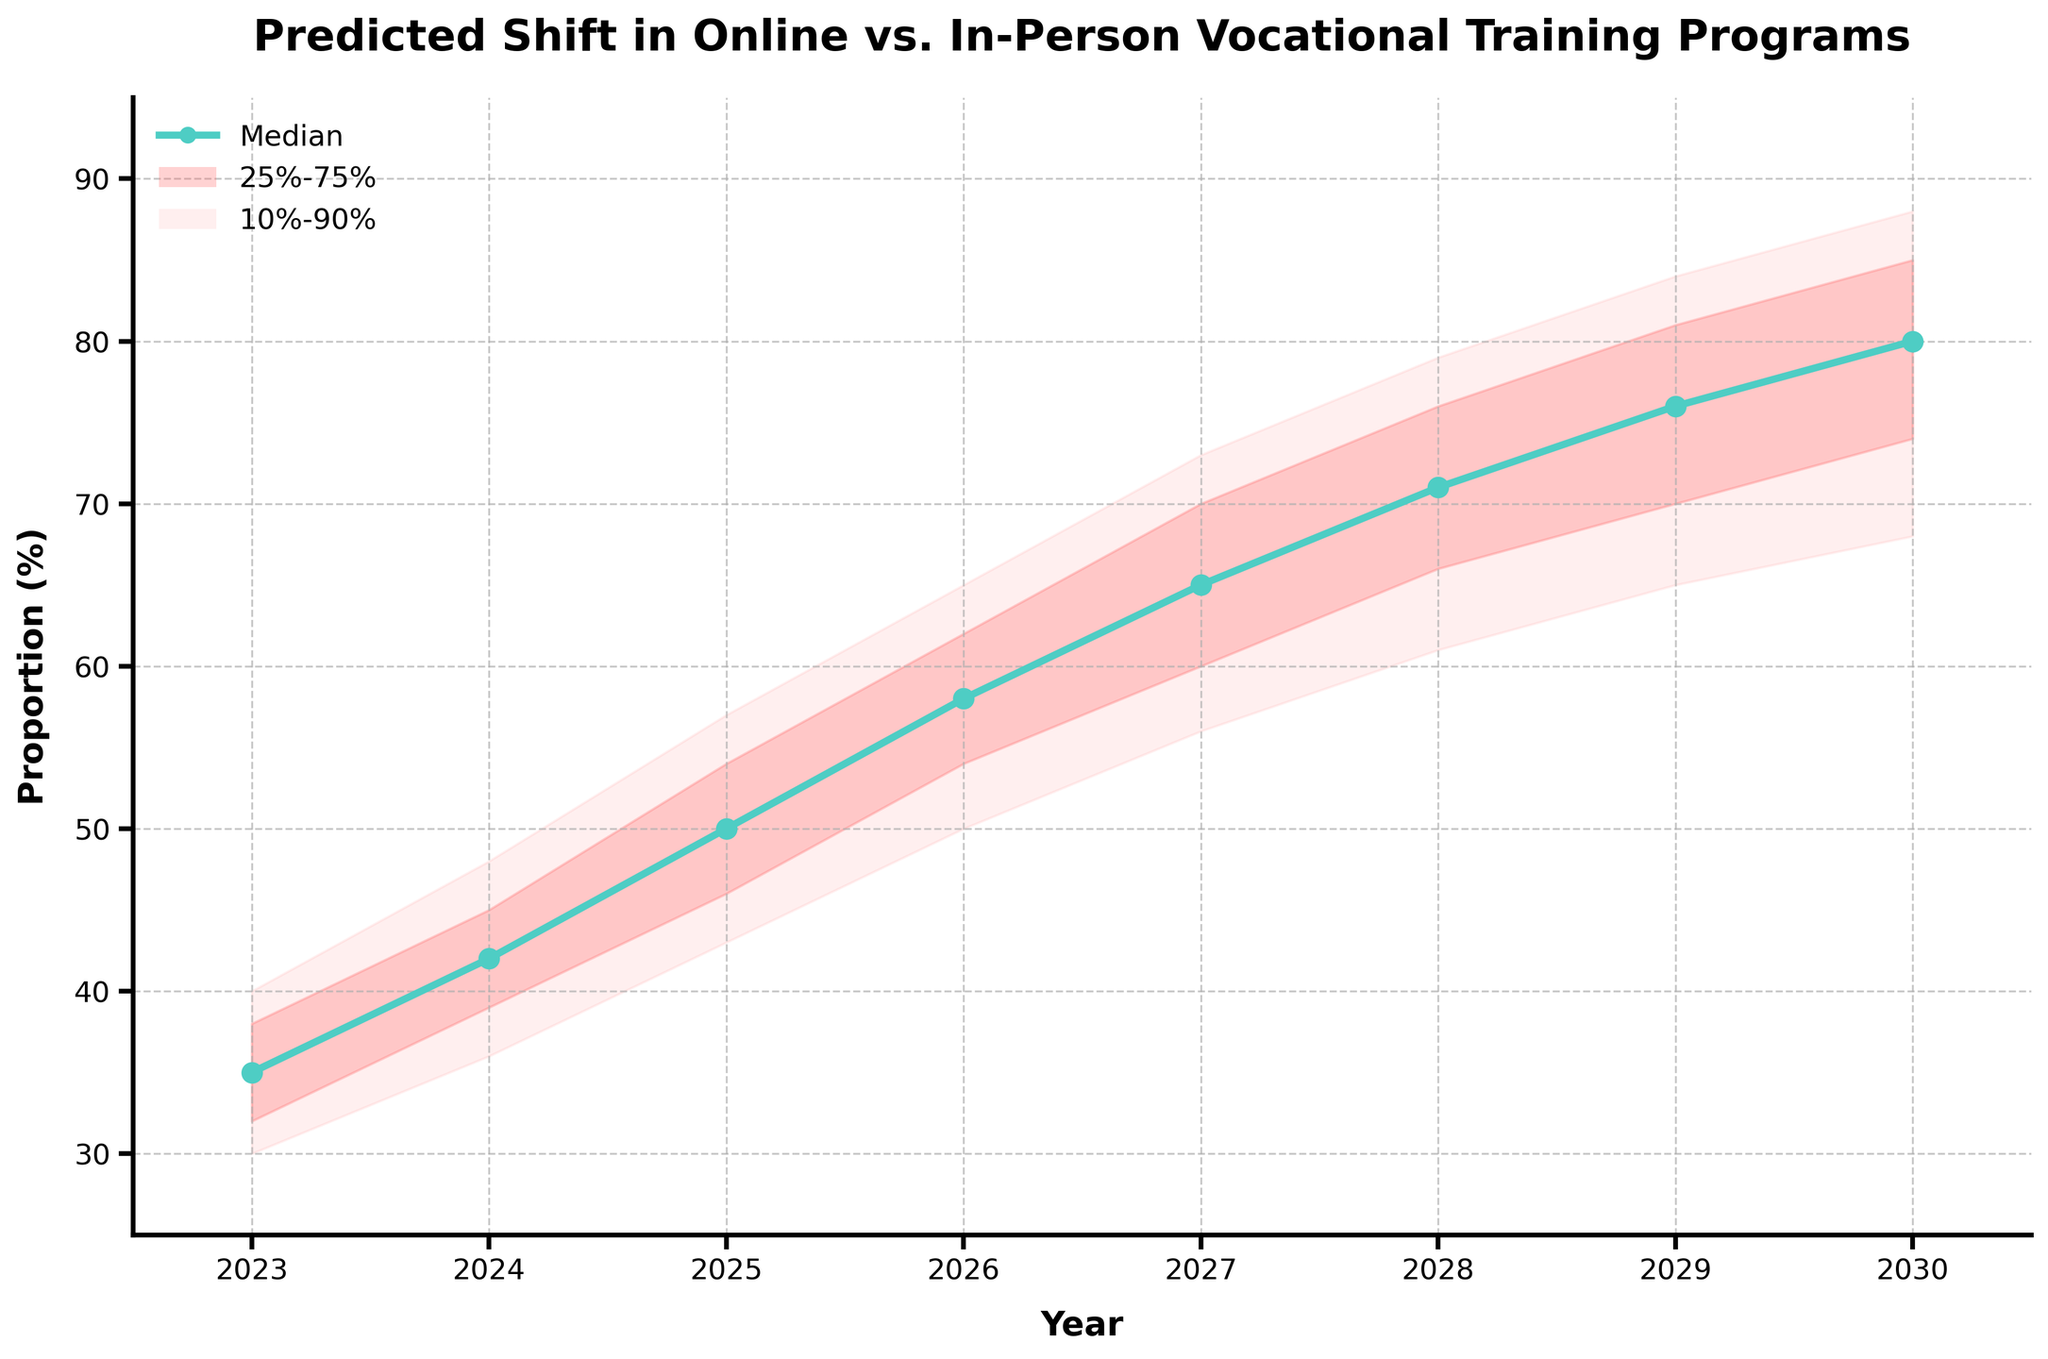What's the title of the chart? The title of the chart is displayed at the top of the figure to give an overview of what the chart represents.
Answer: Predicted Shift in Online vs. In-Person Vocational Training Programs What does the x-axis represent? The x-axis runs horizontally along the bottom of the chart and represents the time period over which the predictions are made.
Answer: Year What does the y-axis represent? The y-axis runs vertically along the left side of the chart and represents the proportion of vocational training programs, expressed as a percentage.
Answer: Proportion (%) How does the proportion of online vocational training programs change from 2023 to 2024 according to the median line? To determine this, find the median values for the years 2023 and 2024 and then calculate the difference.
Answer: Increases by 7% What is the range of predicted values for the year 2026 within the 25%-75% percentile bands? Look for the values corresponding to the lower 25% and upper 75% for the year 2026.
Answer: 54% to 62% In which year is the median predicted proportion of online vocational training programs the highest? Identify the year with the highest point on the median line.
Answer: 2030 What is the difference between the upper 90% prediction interval and the lower 10% prediction interval for the year 2028? Subtract the lower 10% value from the upper 90% value for the year 2028.
Answer: 18% How does the prediction interval (10%-90%) widen or narrow from 2023 to 2030? Compare the width of the prediction interval in 2023 and then in 2030 by looking at the difference between the upper 90% and lower 10% values for each year.
Answer: Widens Which year experiences the largest increase in the median predicted proportion from the previous year? Calculate the year-over-year difference in the median values and identify the year with the largest increase.
Answer: 2025 Is there any year in which the 25%-75% prediction interval does not overlap with the 90% prediction interval of the previous year? Check each year’s 25%-75% interval against the previous year's 90% interval to see if there is a non-overlapping instance.
Answer: No, they all overlap 